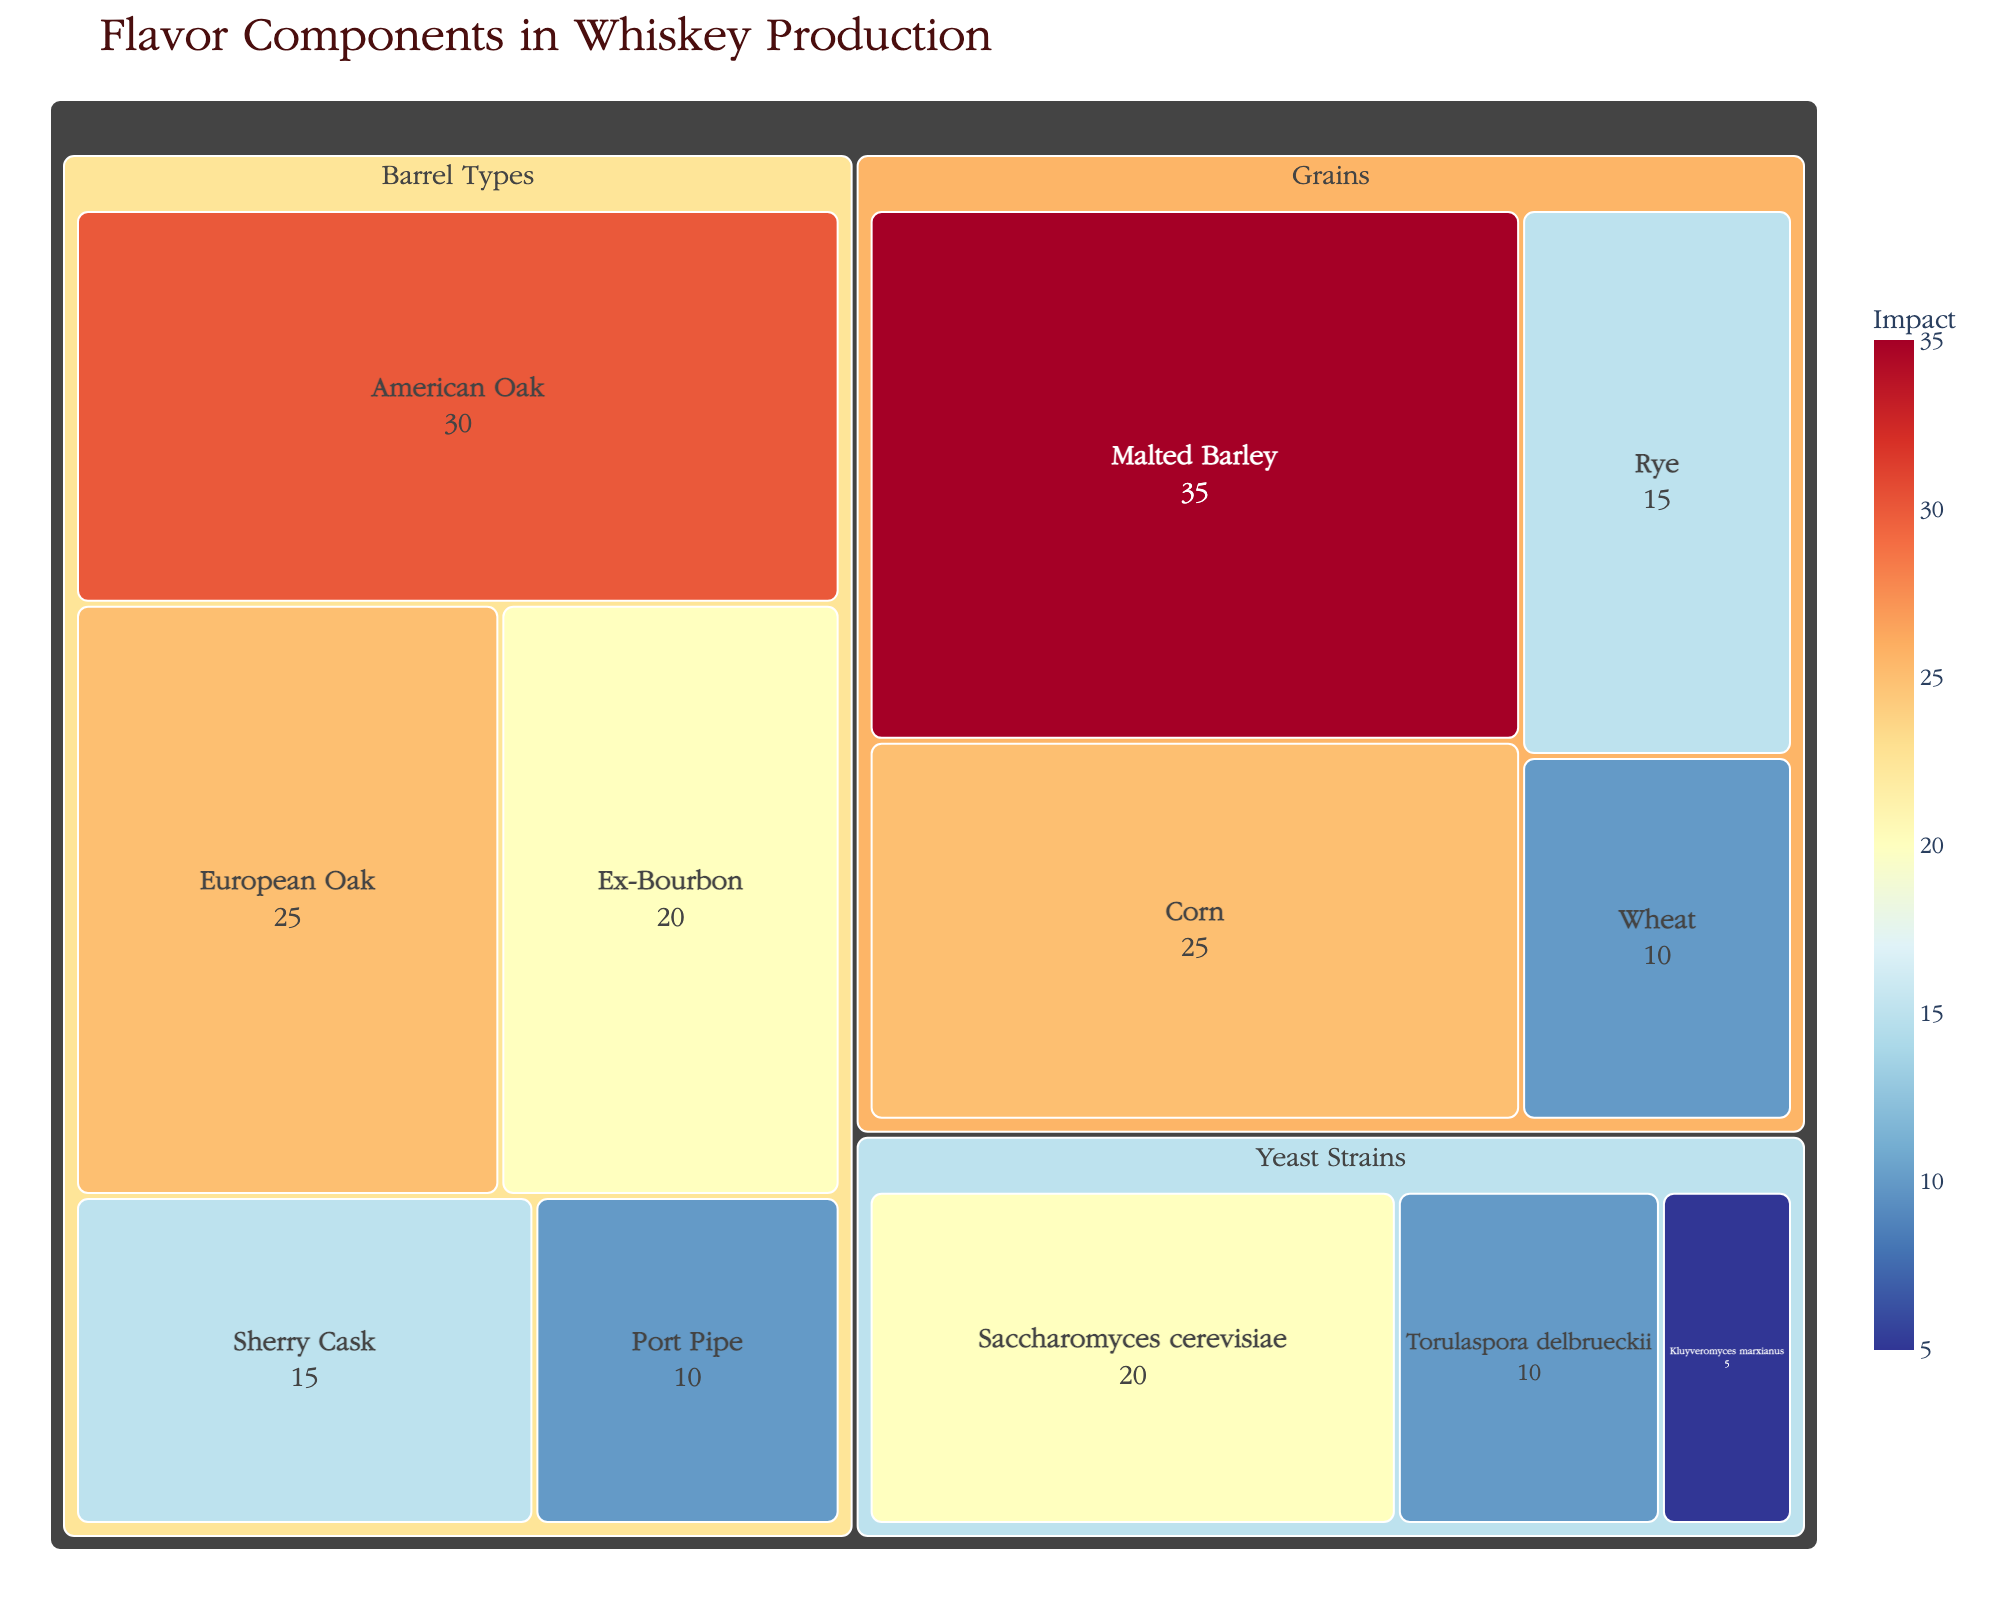What is the title of the figure? The title is located at the top of the figure. It provides an overview of what the data represents.
Answer: Flavor Components in Whiskey Production Which grain has the highest impact on taste? Look for the grain category and identify which subcategory has the highest relative impact value.
Answer: Malted Barley How much impact does American Oak have compared to Port Pipe? Identify the impact values for both American Oak and Port Pipe, then compare them. American Oak has an impact value of 30 and Port Pipe has 10.
Answer: American Oak has 20 more impact compared to Port Pipe What is the combined impact of Rye and Wheat in whiskey production? Locate the impact values for both Rye (15) and Wheat (10) and add them together.
Answer: 25 How many different barrel types are included in the figure? Count the number of subcategories listed under the Barrel Types category.
Answer: 5 Which category contributes most significantly to the flavor components? Compare the sum of impacts within each category: Grains (85), Yeast Strains (35), Barrel Types (100). Barrel Types have the highest combined impact.
Answer: Barrel Types What is the difference in impact between Saccharomyces cerevisiae and Kluyveromyces marxianus yeast strains? Locate the impact values for Saccharomyces cerevisiae (20) and Kluyveromyces marxianus (5) and find the difference between them.
Answer: 15 Which subcategory under Barrel Types has the second-highest impact on whiskey production? Identify all subcategories under Barrel Types and their impact values. The subcategory with the second-highest impact is European Oak with an impact of 25.
Answer: European Oak What is the average impact of all yeast strains on taste? Find the impact values of all yeast strains: Saccharomyces cerevisiae (20), Torulaspora delbrueckii (10), Kluyveromyces marxianus (5), then calculate the average: (20+10+5)/3.
Answer: 11.67 Between grains and yeast strains, which category has greater individual variation among its subcategories' impacts? Calculate the range for both categories: Grains (35-10=25), Yeast Strains (20-5=15). Grains have a greater individual variation.
Answer: Grains 